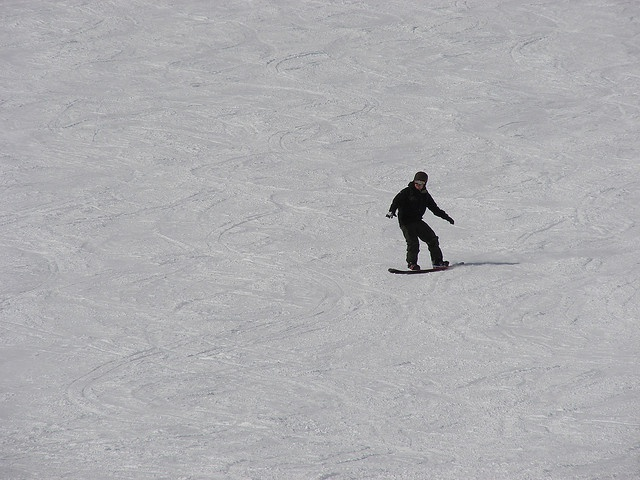Describe the objects in this image and their specific colors. I can see people in darkgray, black, gray, and lightgray tones and snowboard in darkgray, black, gray, and maroon tones in this image. 